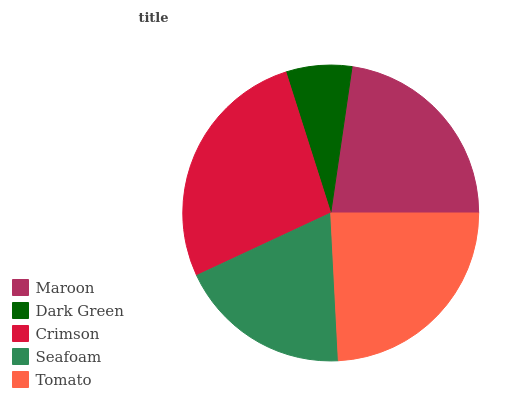Is Dark Green the minimum?
Answer yes or no. Yes. Is Crimson the maximum?
Answer yes or no. Yes. Is Crimson the minimum?
Answer yes or no. No. Is Dark Green the maximum?
Answer yes or no. No. Is Crimson greater than Dark Green?
Answer yes or no. Yes. Is Dark Green less than Crimson?
Answer yes or no. Yes. Is Dark Green greater than Crimson?
Answer yes or no. No. Is Crimson less than Dark Green?
Answer yes or no. No. Is Maroon the high median?
Answer yes or no. Yes. Is Maroon the low median?
Answer yes or no. Yes. Is Seafoam the high median?
Answer yes or no. No. Is Crimson the low median?
Answer yes or no. No. 